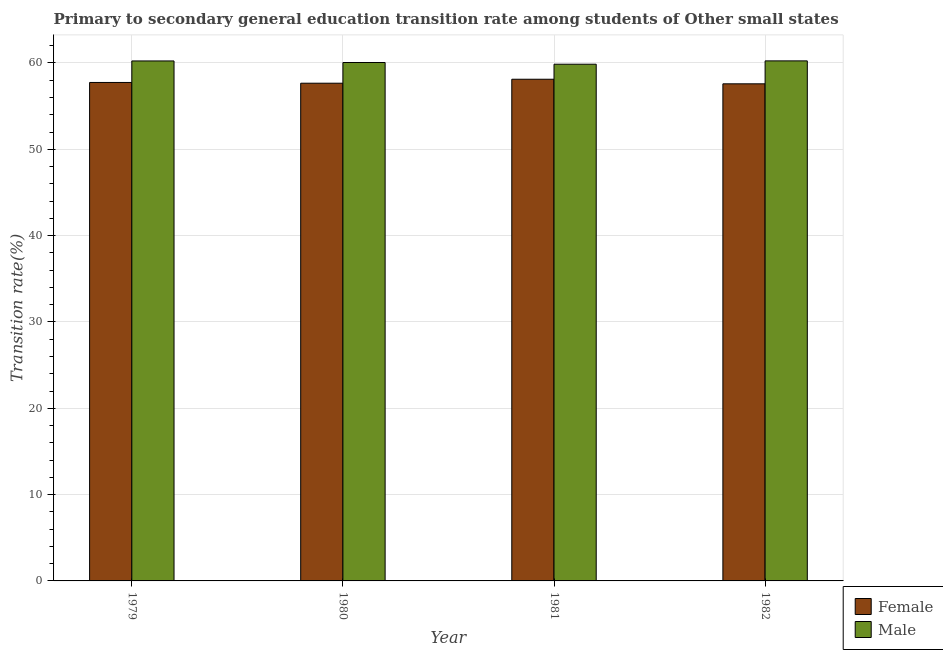How many different coloured bars are there?
Provide a succinct answer. 2. Are the number of bars on each tick of the X-axis equal?
Make the answer very short. Yes. How many bars are there on the 1st tick from the left?
Provide a succinct answer. 2. How many bars are there on the 4th tick from the right?
Your answer should be compact. 2. What is the label of the 2nd group of bars from the left?
Provide a succinct answer. 1980. In how many cases, is the number of bars for a given year not equal to the number of legend labels?
Make the answer very short. 0. What is the transition rate among male students in 1981?
Your answer should be compact. 59.86. Across all years, what is the maximum transition rate among female students?
Offer a very short reply. 58.12. Across all years, what is the minimum transition rate among male students?
Ensure brevity in your answer.  59.86. In which year was the transition rate among male students maximum?
Keep it short and to the point. 1982. What is the total transition rate among female students in the graph?
Give a very brief answer. 231.1. What is the difference between the transition rate among female students in 1979 and that in 1980?
Make the answer very short. 0.09. What is the difference between the transition rate among male students in 1980 and the transition rate among female students in 1981?
Your response must be concise. 0.2. What is the average transition rate among female students per year?
Your answer should be very brief. 57.77. What is the ratio of the transition rate among female students in 1979 to that in 1980?
Provide a succinct answer. 1. Is the difference between the transition rate among female students in 1981 and 1982 greater than the difference between the transition rate among male students in 1981 and 1982?
Provide a short and direct response. No. What is the difference between the highest and the second highest transition rate among male students?
Keep it short and to the point. 0.01. What is the difference between the highest and the lowest transition rate among male students?
Your response must be concise. 0.39. In how many years, is the transition rate among female students greater than the average transition rate among female students taken over all years?
Provide a succinct answer. 1. Is the sum of the transition rate among female students in 1980 and 1981 greater than the maximum transition rate among male students across all years?
Offer a terse response. Yes. What does the 1st bar from the right in 1979 represents?
Your answer should be compact. Male. How many bars are there?
Ensure brevity in your answer.  8. What is the difference between two consecutive major ticks on the Y-axis?
Provide a short and direct response. 10. Does the graph contain any zero values?
Provide a short and direct response. No. Where does the legend appear in the graph?
Ensure brevity in your answer.  Bottom right. What is the title of the graph?
Your answer should be very brief. Primary to secondary general education transition rate among students of Other small states. Does "Gasoline" appear as one of the legend labels in the graph?
Your response must be concise. No. What is the label or title of the X-axis?
Offer a terse response. Year. What is the label or title of the Y-axis?
Your answer should be very brief. Transition rate(%). What is the Transition rate(%) of Female in 1979?
Provide a succinct answer. 57.74. What is the Transition rate(%) in Male in 1979?
Your answer should be very brief. 60.23. What is the Transition rate(%) in Female in 1980?
Your answer should be compact. 57.66. What is the Transition rate(%) in Male in 1980?
Your answer should be compact. 60.05. What is the Transition rate(%) in Female in 1981?
Make the answer very short. 58.12. What is the Transition rate(%) in Male in 1981?
Your response must be concise. 59.86. What is the Transition rate(%) in Female in 1982?
Provide a succinct answer. 57.58. What is the Transition rate(%) of Male in 1982?
Give a very brief answer. 60.24. Across all years, what is the maximum Transition rate(%) of Female?
Give a very brief answer. 58.12. Across all years, what is the maximum Transition rate(%) of Male?
Provide a short and direct response. 60.24. Across all years, what is the minimum Transition rate(%) of Female?
Offer a very short reply. 57.58. Across all years, what is the minimum Transition rate(%) in Male?
Keep it short and to the point. 59.86. What is the total Transition rate(%) of Female in the graph?
Make the answer very short. 231.1. What is the total Transition rate(%) in Male in the graph?
Make the answer very short. 240.39. What is the difference between the Transition rate(%) in Female in 1979 and that in 1980?
Give a very brief answer. 0.09. What is the difference between the Transition rate(%) of Male in 1979 and that in 1980?
Your response must be concise. 0.18. What is the difference between the Transition rate(%) in Female in 1979 and that in 1981?
Provide a short and direct response. -0.37. What is the difference between the Transition rate(%) in Male in 1979 and that in 1981?
Offer a terse response. 0.38. What is the difference between the Transition rate(%) of Female in 1979 and that in 1982?
Keep it short and to the point. 0.16. What is the difference between the Transition rate(%) in Male in 1979 and that in 1982?
Give a very brief answer. -0.01. What is the difference between the Transition rate(%) in Female in 1980 and that in 1981?
Keep it short and to the point. -0.46. What is the difference between the Transition rate(%) in Male in 1980 and that in 1981?
Your answer should be compact. 0.2. What is the difference between the Transition rate(%) in Female in 1980 and that in 1982?
Your answer should be very brief. 0.07. What is the difference between the Transition rate(%) of Male in 1980 and that in 1982?
Provide a short and direct response. -0.19. What is the difference between the Transition rate(%) of Female in 1981 and that in 1982?
Give a very brief answer. 0.53. What is the difference between the Transition rate(%) of Male in 1981 and that in 1982?
Your response must be concise. -0.39. What is the difference between the Transition rate(%) of Female in 1979 and the Transition rate(%) of Male in 1980?
Offer a terse response. -2.31. What is the difference between the Transition rate(%) in Female in 1979 and the Transition rate(%) in Male in 1981?
Provide a short and direct response. -2.11. What is the difference between the Transition rate(%) in Female in 1979 and the Transition rate(%) in Male in 1982?
Provide a short and direct response. -2.5. What is the difference between the Transition rate(%) in Female in 1980 and the Transition rate(%) in Male in 1981?
Offer a very short reply. -2.2. What is the difference between the Transition rate(%) in Female in 1980 and the Transition rate(%) in Male in 1982?
Keep it short and to the point. -2.59. What is the difference between the Transition rate(%) of Female in 1981 and the Transition rate(%) of Male in 1982?
Ensure brevity in your answer.  -2.13. What is the average Transition rate(%) in Female per year?
Give a very brief answer. 57.77. What is the average Transition rate(%) of Male per year?
Provide a succinct answer. 60.1. In the year 1979, what is the difference between the Transition rate(%) of Female and Transition rate(%) of Male?
Offer a very short reply. -2.49. In the year 1980, what is the difference between the Transition rate(%) of Female and Transition rate(%) of Male?
Your answer should be compact. -2.4. In the year 1981, what is the difference between the Transition rate(%) in Female and Transition rate(%) in Male?
Provide a succinct answer. -1.74. In the year 1982, what is the difference between the Transition rate(%) of Female and Transition rate(%) of Male?
Make the answer very short. -2.66. What is the ratio of the Transition rate(%) in Female in 1979 to that in 1980?
Your answer should be compact. 1. What is the ratio of the Transition rate(%) of Female in 1979 to that in 1981?
Make the answer very short. 0.99. What is the ratio of the Transition rate(%) in Male in 1979 to that in 1981?
Offer a terse response. 1.01. What is the ratio of the Transition rate(%) in Female in 1979 to that in 1982?
Your response must be concise. 1. What is the ratio of the Transition rate(%) in Female in 1980 to that in 1982?
Keep it short and to the point. 1. What is the ratio of the Transition rate(%) in Female in 1981 to that in 1982?
Make the answer very short. 1.01. What is the difference between the highest and the second highest Transition rate(%) of Female?
Offer a terse response. 0.37. What is the difference between the highest and the second highest Transition rate(%) of Male?
Offer a terse response. 0.01. What is the difference between the highest and the lowest Transition rate(%) in Female?
Offer a very short reply. 0.53. What is the difference between the highest and the lowest Transition rate(%) of Male?
Your answer should be compact. 0.39. 